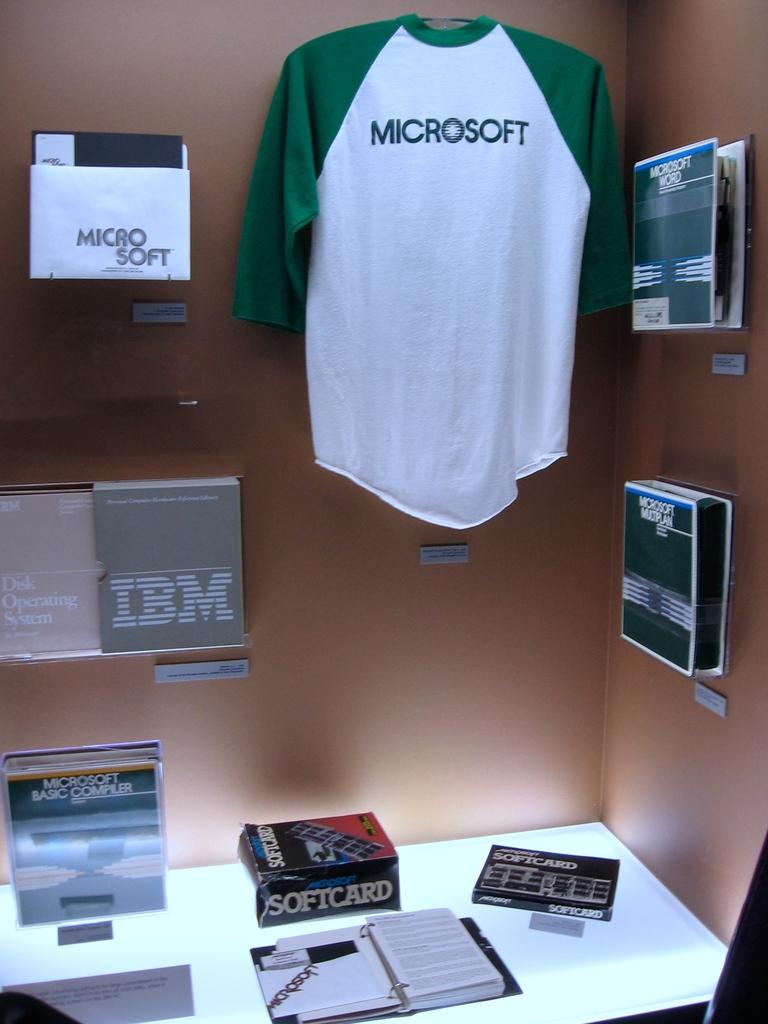<image>
Give a short and clear explanation of the subsequent image. A display of different computer brands such as IBM and Microsoft. 